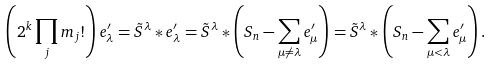Convert formula to latex. <formula><loc_0><loc_0><loc_500><loc_500>\left ( 2 ^ { k } \prod _ { j } m _ { j } ! \right ) e ^ { \prime } _ { \lambda } = \tilde { S } ^ { \lambda } * e ^ { \prime } _ { \lambda } = \tilde { S } ^ { \lambda } * \left ( S _ { n } - \sum _ { \mu \neq \lambda } e ^ { \prime } _ { \mu } \right ) = \tilde { S } ^ { \lambda } * \left ( S _ { n } - \sum _ { \mu < \lambda } e ^ { \prime } _ { \mu } \right ) .</formula> 